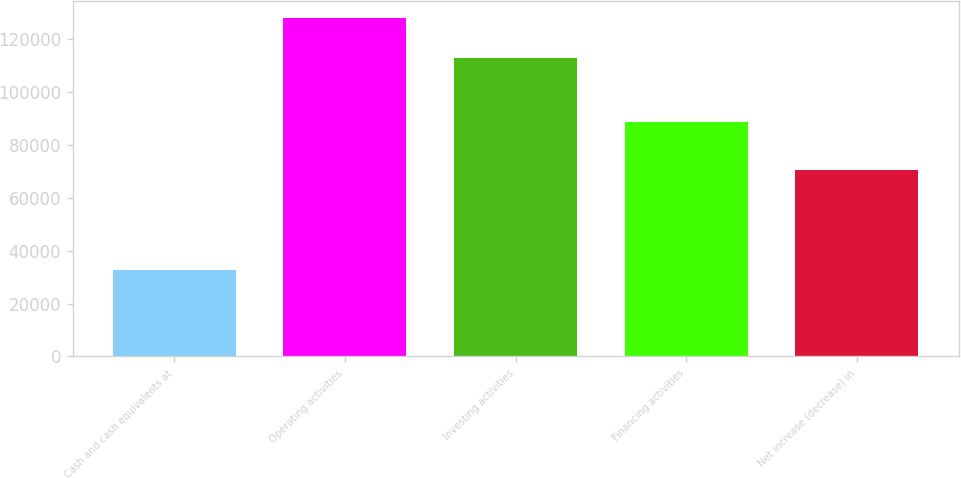Convert chart to OTSL. <chart><loc_0><loc_0><loc_500><loc_500><bar_chart><fcel>Cash and cash equivalents at<fcel>Operating activities<fcel>Investing activities<fcel>Financing activities<fcel>Net increase (decrease) in<nl><fcel>32741<fcel>127797<fcel>112574<fcel>88624<fcel>70327<nl></chart> 